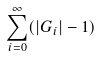Convert formula to latex. <formula><loc_0><loc_0><loc_500><loc_500>\sum _ { i = 0 } ^ { \infty } ( | G _ { i } | - 1 )</formula> 